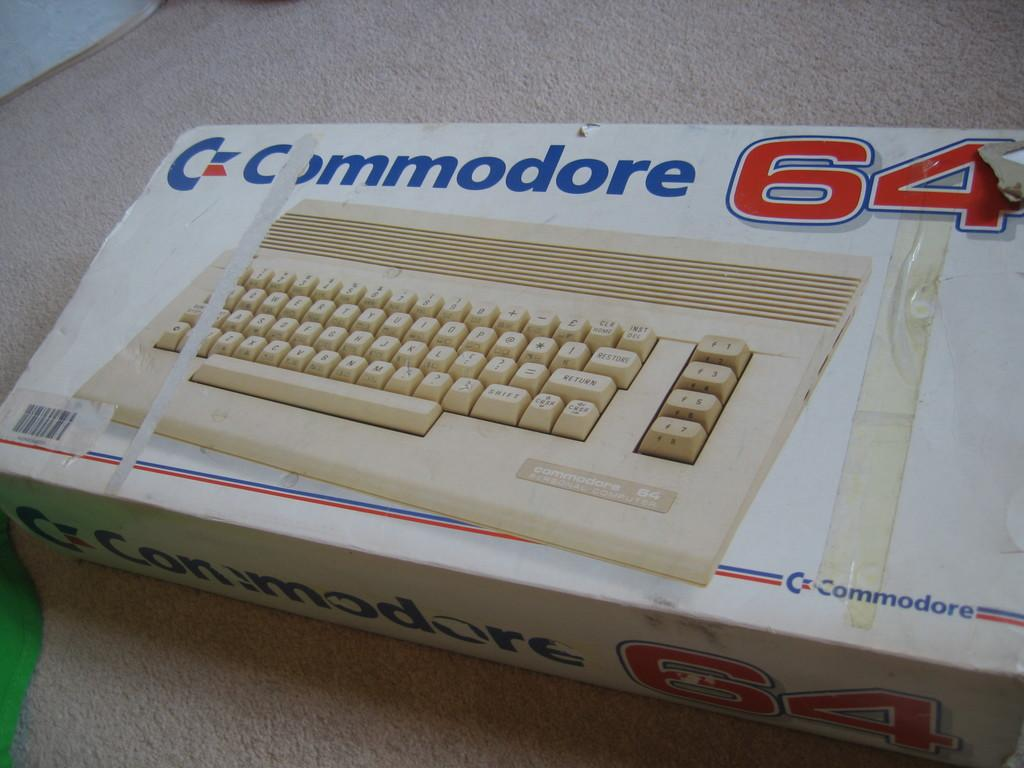What is depicted on the cardboard box in the image? There is a picture of a keyboard on the cardboard box. What additional feature can be seen on the cardboard box? The cardboard box has a barcode. Where is the cardboard box located in the image? The cardboard box is placed on the floor. What type of fowl can be seen sitting on the keyboard in the image? There is no fowl present in the image; it only shows a cardboard box with a keyboard picture. What color is the ink used to print the keyboard picture on the cardboard box? The image does not provide information about the color of the ink used to print the keyboard picture on the cardboard box. 